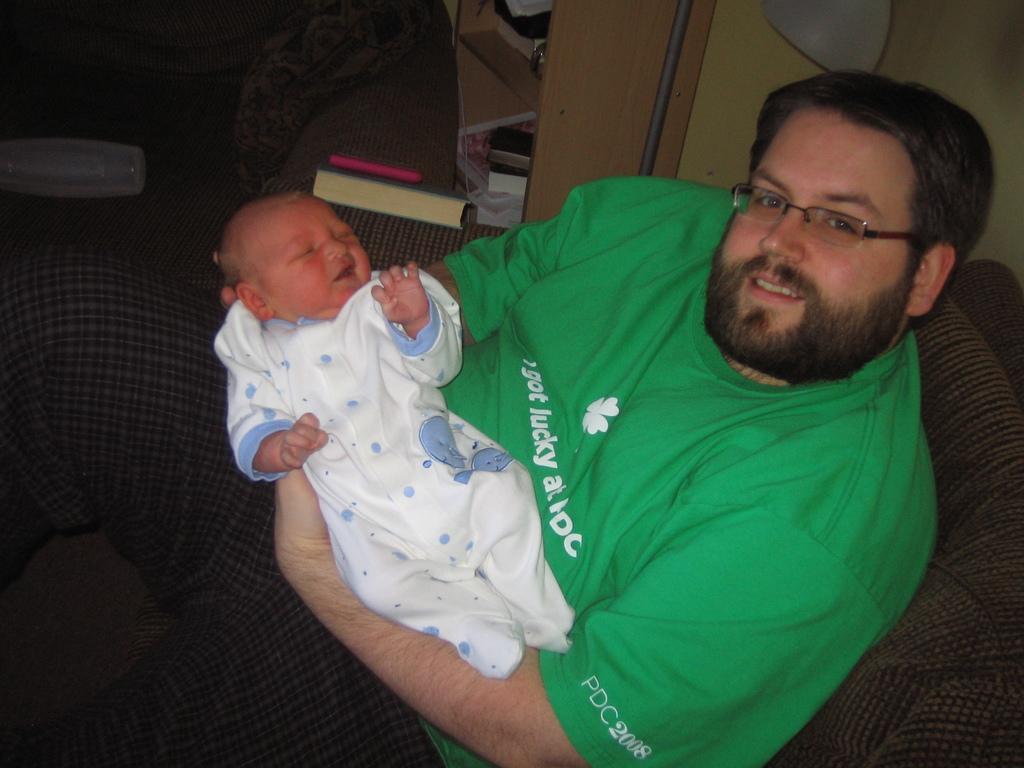Describe this image in one or two sentences. In the image in the center we can see one person sitting on the couch and he is holding a baby. And he is smiling,which we can see on his face. And he is wearing green color t shirt. In the background there is a wall,shelf,books,phone and few other objects. 